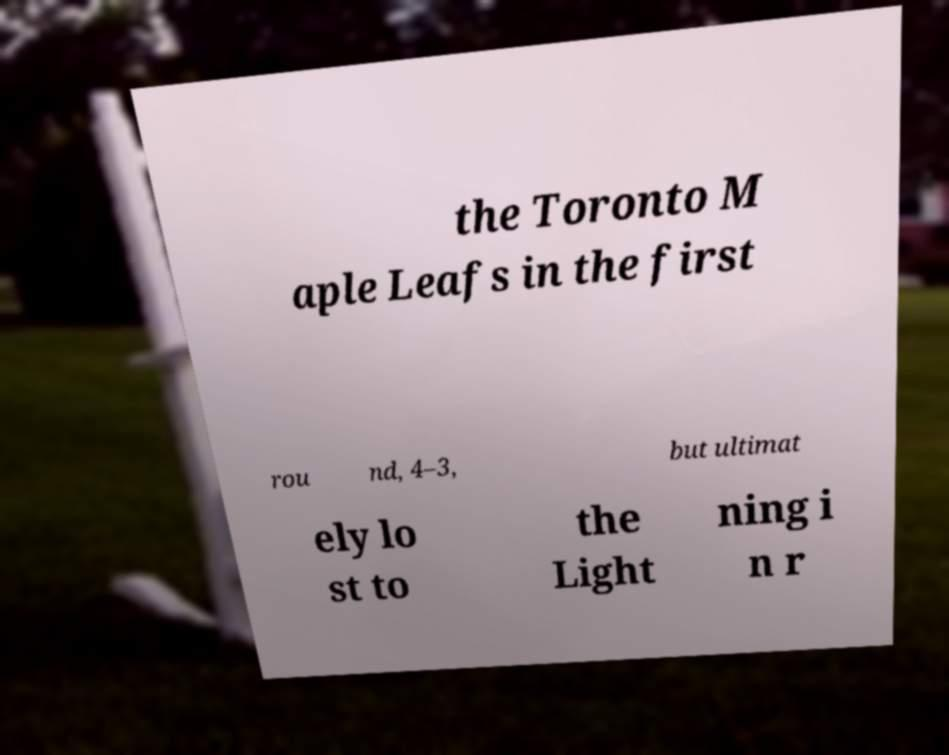What messages or text are displayed in this image? I need them in a readable, typed format. the Toronto M aple Leafs in the first rou nd, 4–3, but ultimat ely lo st to the Light ning i n r 